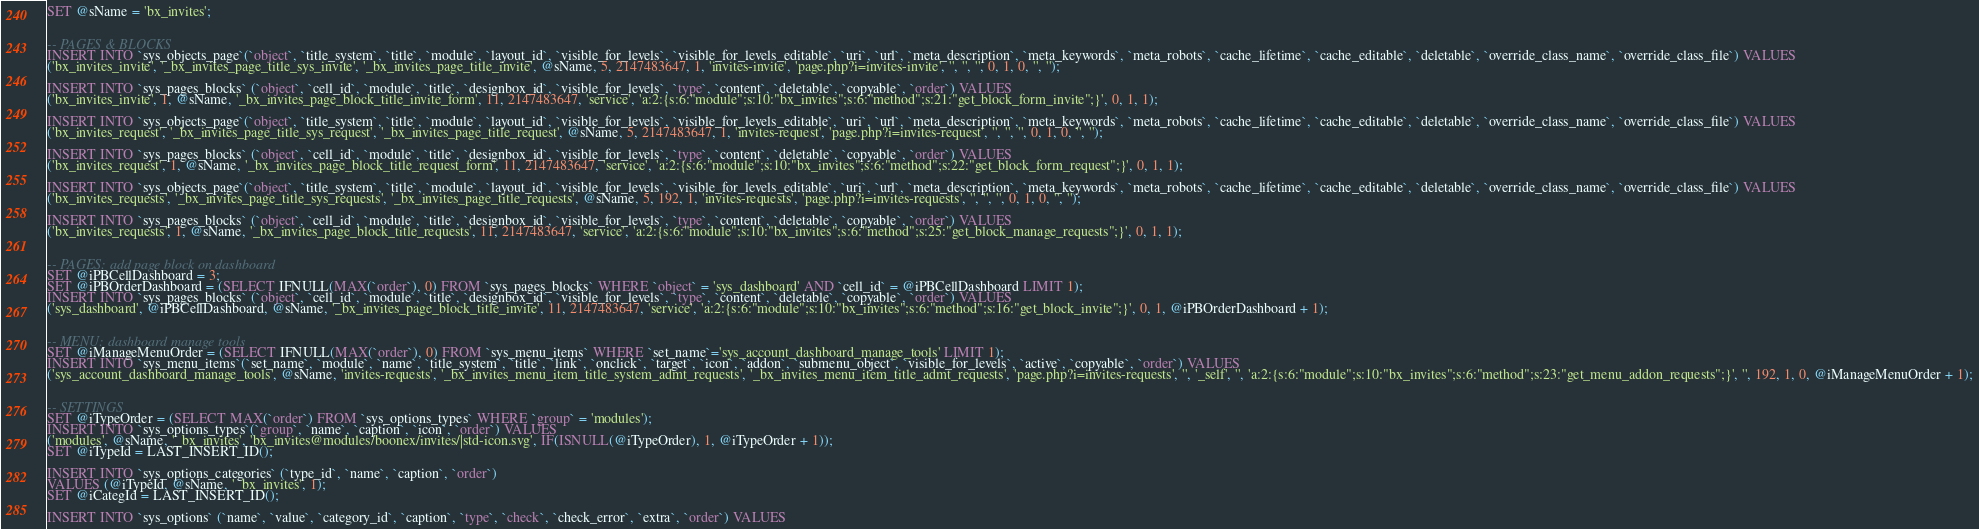Convert code to text. <code><loc_0><loc_0><loc_500><loc_500><_SQL_>SET @sName = 'bx_invites';


-- PAGES & BLOCKS
INSERT INTO `sys_objects_page`(`object`, `title_system`, `title`, `module`, `layout_id`, `visible_for_levels`, `visible_for_levels_editable`, `uri`, `url`, `meta_description`, `meta_keywords`, `meta_robots`, `cache_lifetime`, `cache_editable`, `deletable`, `override_class_name`, `override_class_file`) VALUES 
('bx_invites_invite', '_bx_invites_page_title_sys_invite', '_bx_invites_page_title_invite', @sName, 5, 2147483647, 1, 'invites-invite', 'page.php?i=invites-invite', '', '', '', 0, 1, 0, '', '');

INSERT INTO `sys_pages_blocks` (`object`, `cell_id`, `module`, `title`, `designbox_id`, `visible_for_levels`, `type`, `content`, `deletable`, `copyable`, `order`) VALUES
('bx_invites_invite', 1, @sName, '_bx_invites_page_block_title_invite_form', 11, 2147483647, 'service', 'a:2:{s:6:"module";s:10:"bx_invites";s:6:"method";s:21:"get_block_form_invite";}', 0, 1, 1);

INSERT INTO `sys_objects_page`(`object`, `title_system`, `title`, `module`, `layout_id`, `visible_for_levels`, `visible_for_levels_editable`, `uri`, `url`, `meta_description`, `meta_keywords`, `meta_robots`, `cache_lifetime`, `cache_editable`, `deletable`, `override_class_name`, `override_class_file`) VALUES 
('bx_invites_request', '_bx_invites_page_title_sys_request', '_bx_invites_page_title_request', @sName, 5, 2147483647, 1, 'invites-request', 'page.php?i=invites-request', '', '', '', 0, 1, 0, '', '');

INSERT INTO `sys_pages_blocks` (`object`, `cell_id`, `module`, `title`, `designbox_id`, `visible_for_levels`, `type`, `content`, `deletable`, `copyable`, `order`) VALUES
('bx_invites_request', 1, @sName, '_bx_invites_page_block_title_request_form', 11, 2147483647, 'service', 'a:2:{s:6:"module";s:10:"bx_invites";s:6:"method";s:22:"get_block_form_request";}', 0, 1, 1);

INSERT INTO `sys_objects_page`(`object`, `title_system`, `title`, `module`, `layout_id`, `visible_for_levels`, `visible_for_levels_editable`, `uri`, `url`, `meta_description`, `meta_keywords`, `meta_robots`, `cache_lifetime`, `cache_editable`, `deletable`, `override_class_name`, `override_class_file`) VALUES 
('bx_invites_requests', '_bx_invites_page_title_sys_requests', '_bx_invites_page_title_requests', @sName, 5, 192, 1, 'invites-requests', 'page.php?i=invites-requests', '', '', '', 0, 1, 0, '', '');

INSERT INTO `sys_pages_blocks` (`object`, `cell_id`, `module`, `title`, `designbox_id`, `visible_for_levels`, `type`, `content`, `deletable`, `copyable`, `order`) VALUES
('bx_invites_requests', 1, @sName, '_bx_invites_page_block_title_requests', 11, 2147483647, 'service', 'a:2:{s:6:"module";s:10:"bx_invites";s:6:"method";s:25:"get_block_manage_requests";}', 0, 1, 1);


-- PAGES: add page block on dashboard
SET @iPBCellDashboard = 3;
SET @iPBOrderDashboard = (SELECT IFNULL(MAX(`order`), 0) FROM `sys_pages_blocks` WHERE `object` = 'sys_dashboard' AND `cell_id` = @iPBCellDashboard LIMIT 1);
INSERT INTO `sys_pages_blocks` (`object`, `cell_id`, `module`, `title`, `designbox_id`, `visible_for_levels`, `type`, `content`, `deletable`, `copyable`, `order`) VALUES
('sys_dashboard', @iPBCellDashboard, @sName, '_bx_invites_page_block_title_invite', 11, 2147483647, 'service', 'a:2:{s:6:"module";s:10:"bx_invites";s:6:"method";s:16:"get_block_invite";}', 0, 1, @iPBOrderDashboard + 1);


-- MENU: dashboard manage tools
SET @iManageMenuOrder = (SELECT IFNULL(MAX(`order`), 0) FROM `sys_menu_items` WHERE `set_name`='sys_account_dashboard_manage_tools' LIMIT 1);
INSERT INTO `sys_menu_items`(`set_name`, `module`, `name`, `title_system`, `title`, `link`, `onclick`, `target`, `icon`, `addon`, `submenu_object`, `visible_for_levels`, `active`, `copyable`, `order`) VALUES 
('sys_account_dashboard_manage_tools', @sName, 'invites-requests', '_bx_invites_menu_item_title_system_admt_requests', '_bx_invites_menu_item_title_admt_requests', 'page.php?i=invites-requests', '', '_self', '', 'a:2:{s:6:"module";s:10:"bx_invites";s:6:"method";s:23:"get_menu_addon_requests";}', '', 192, 1, 0, @iManageMenuOrder + 1);


-- SETTINGS
SET @iTypeOrder = (SELECT MAX(`order`) FROM `sys_options_types` WHERE `group` = 'modules');
INSERT INTO `sys_options_types`(`group`, `name`, `caption`, `icon`, `order`) VALUES 
('modules', @sName, '_bx_invites', 'bx_invites@modules/boonex/invites/|std-icon.svg', IF(ISNULL(@iTypeOrder), 1, @iTypeOrder + 1));
SET @iTypeId = LAST_INSERT_ID();

INSERT INTO `sys_options_categories` (`type_id`, `name`, `caption`, `order`)
VALUES (@iTypeId, @sName, '_bx_invites', 1);
SET @iCategId = LAST_INSERT_ID();

INSERT INTO `sys_options` (`name`, `value`, `category_id`, `caption`, `type`, `check`, `check_error`, `extra`, `order`) VALUES</code> 